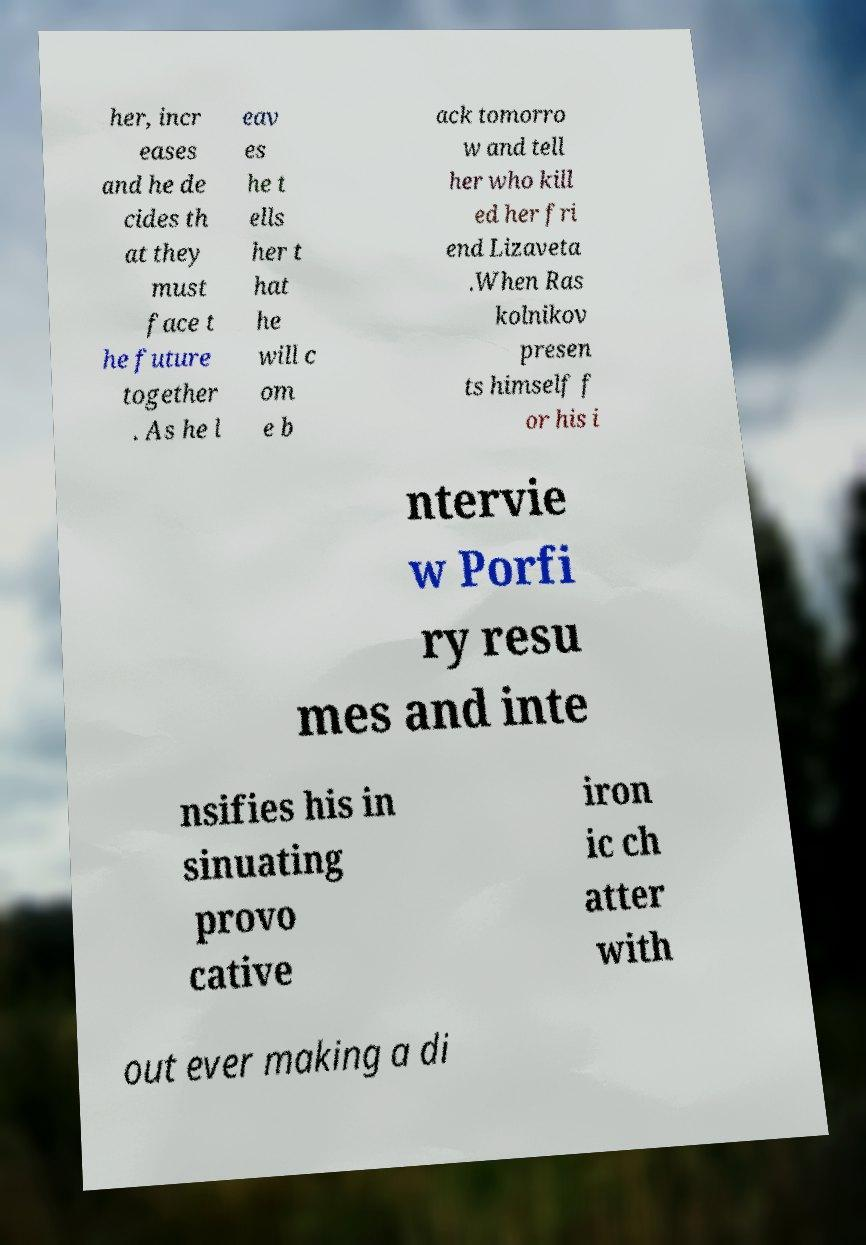What messages or text are displayed in this image? I need them in a readable, typed format. her, incr eases and he de cides th at they must face t he future together . As he l eav es he t ells her t hat he will c om e b ack tomorro w and tell her who kill ed her fri end Lizaveta .When Ras kolnikov presen ts himself f or his i ntervie w Porfi ry resu mes and inte nsifies his in sinuating provo cative iron ic ch atter with out ever making a di 